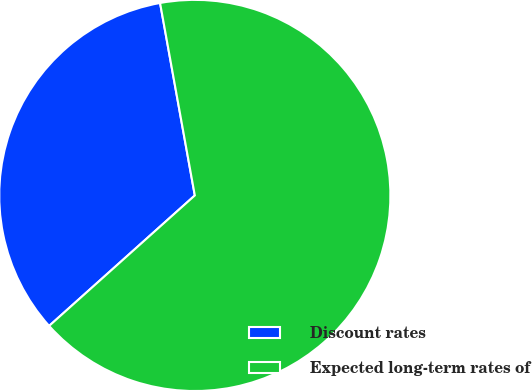Convert chart. <chart><loc_0><loc_0><loc_500><loc_500><pie_chart><fcel>Discount rates<fcel>Expected long-term rates of<nl><fcel>33.78%<fcel>66.22%<nl></chart> 